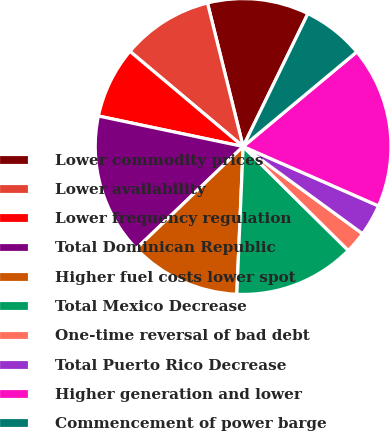<chart> <loc_0><loc_0><loc_500><loc_500><pie_chart><fcel>Lower commodity prices<fcel>Lower availability<fcel>Lower frequency regulation<fcel>Total Dominican Republic<fcel>Higher fuel costs lower spot<fcel>Total Mexico Decrease<fcel>One-time reversal of bad debt<fcel>Total Puerto Rico Decrease<fcel>Higher generation and lower<fcel>Commencement of power barge<nl><fcel>11.09%<fcel>10.0%<fcel>7.82%<fcel>15.45%<fcel>12.18%<fcel>13.27%<fcel>2.37%<fcel>3.46%<fcel>17.63%<fcel>6.73%<nl></chart> 